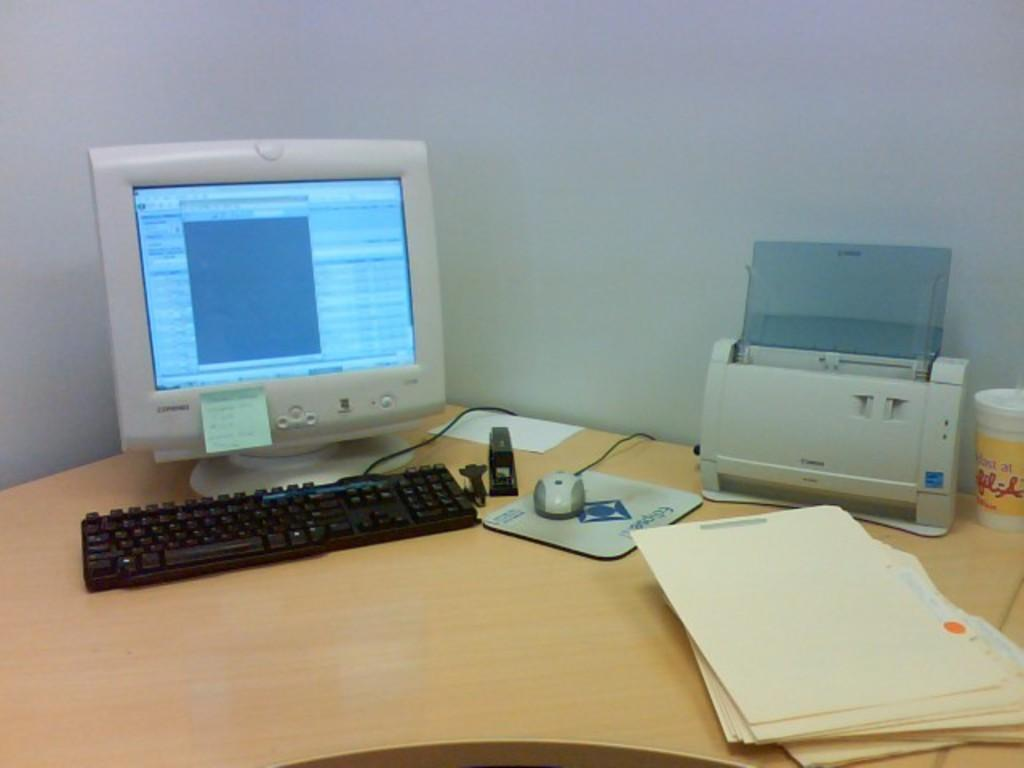What electronic device is on the table in the image? There is a computer monitor on the table. What is used for input with the computer monitor? There is a keyboard and a mouse on the table. What is the mouse placed on? There is a mouse pad on the table. What device is used for printing in the image? There is a printer on the table. What type of material is present on the table? There are papers on the table. What can be seen in the background of the image? There is a wall in the background. What direction is the bike facing in the image? There is no bike present in the image. What type of headwear is the person wearing in the image? There is no person or headwear visible in the image. 